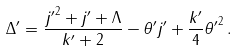<formula> <loc_0><loc_0><loc_500><loc_500>\Delta ^ { \prime } = \frac { { j ^ { \prime } } ^ { 2 } + j ^ { \prime } + \Lambda } { k ^ { \prime } + 2 } - \theta ^ { \prime } j ^ { \prime } + \frac { k ^ { \prime } } { 4 } { \theta ^ { \prime } } ^ { 2 } \, .</formula> 